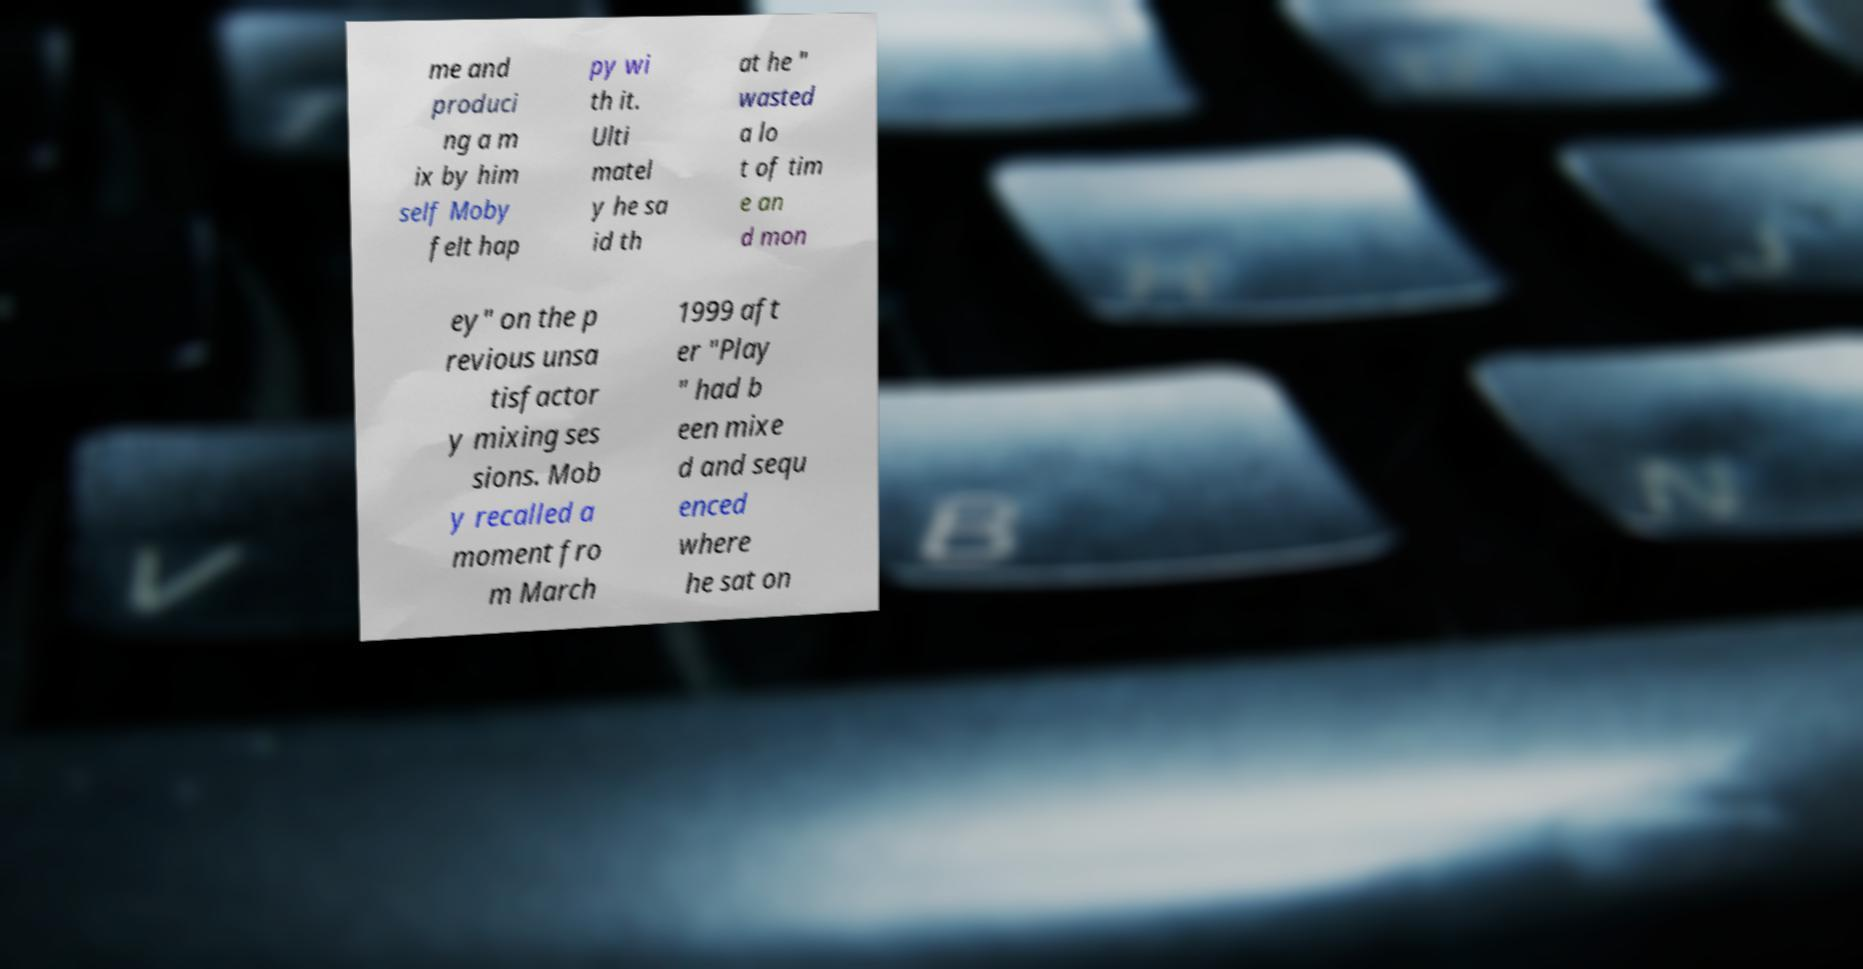Could you assist in decoding the text presented in this image and type it out clearly? me and produci ng a m ix by him self Moby felt hap py wi th it. Ulti matel y he sa id th at he " wasted a lo t of tim e an d mon ey" on the p revious unsa tisfactor y mixing ses sions. Mob y recalled a moment fro m March 1999 aft er "Play " had b een mixe d and sequ enced where he sat on 